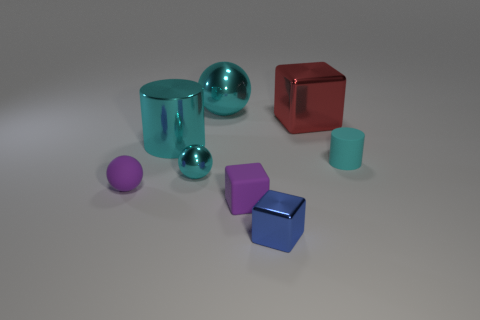Subtract all tiny purple matte spheres. How many spheres are left? 2 Subtract all cyan spheres. How many spheres are left? 1 Add 1 large cyan metallic balls. How many objects exist? 9 Subtract all cylinders. How many objects are left? 6 Subtract 1 cylinders. How many cylinders are left? 1 Subtract all green cylinders. Subtract all green blocks. How many cylinders are left? 2 Subtract all gray cubes. How many gray balls are left? 0 Subtract all small purple rubber spheres. Subtract all cyan metal cylinders. How many objects are left? 6 Add 6 large metal cubes. How many large metal cubes are left? 7 Add 3 tiny purple shiny spheres. How many tiny purple shiny spheres exist? 3 